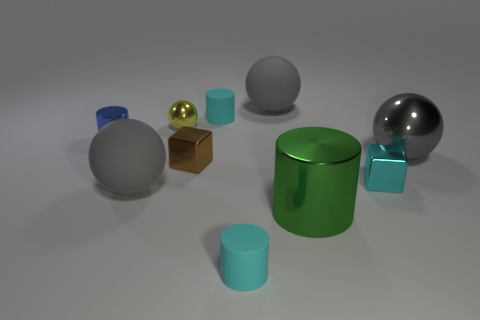Subtract all blue cylinders. How many gray balls are left? 3 Subtract 1 cylinders. How many cylinders are left? 3 Subtract all purple balls. Subtract all purple blocks. How many balls are left? 4 Subtract all spheres. How many objects are left? 6 Add 5 tiny metallic balls. How many tiny metallic balls are left? 6 Add 8 big rubber spheres. How many big rubber spheres exist? 10 Subtract 1 green cylinders. How many objects are left? 9 Subtract all small brown metal blocks. Subtract all blue cylinders. How many objects are left? 8 